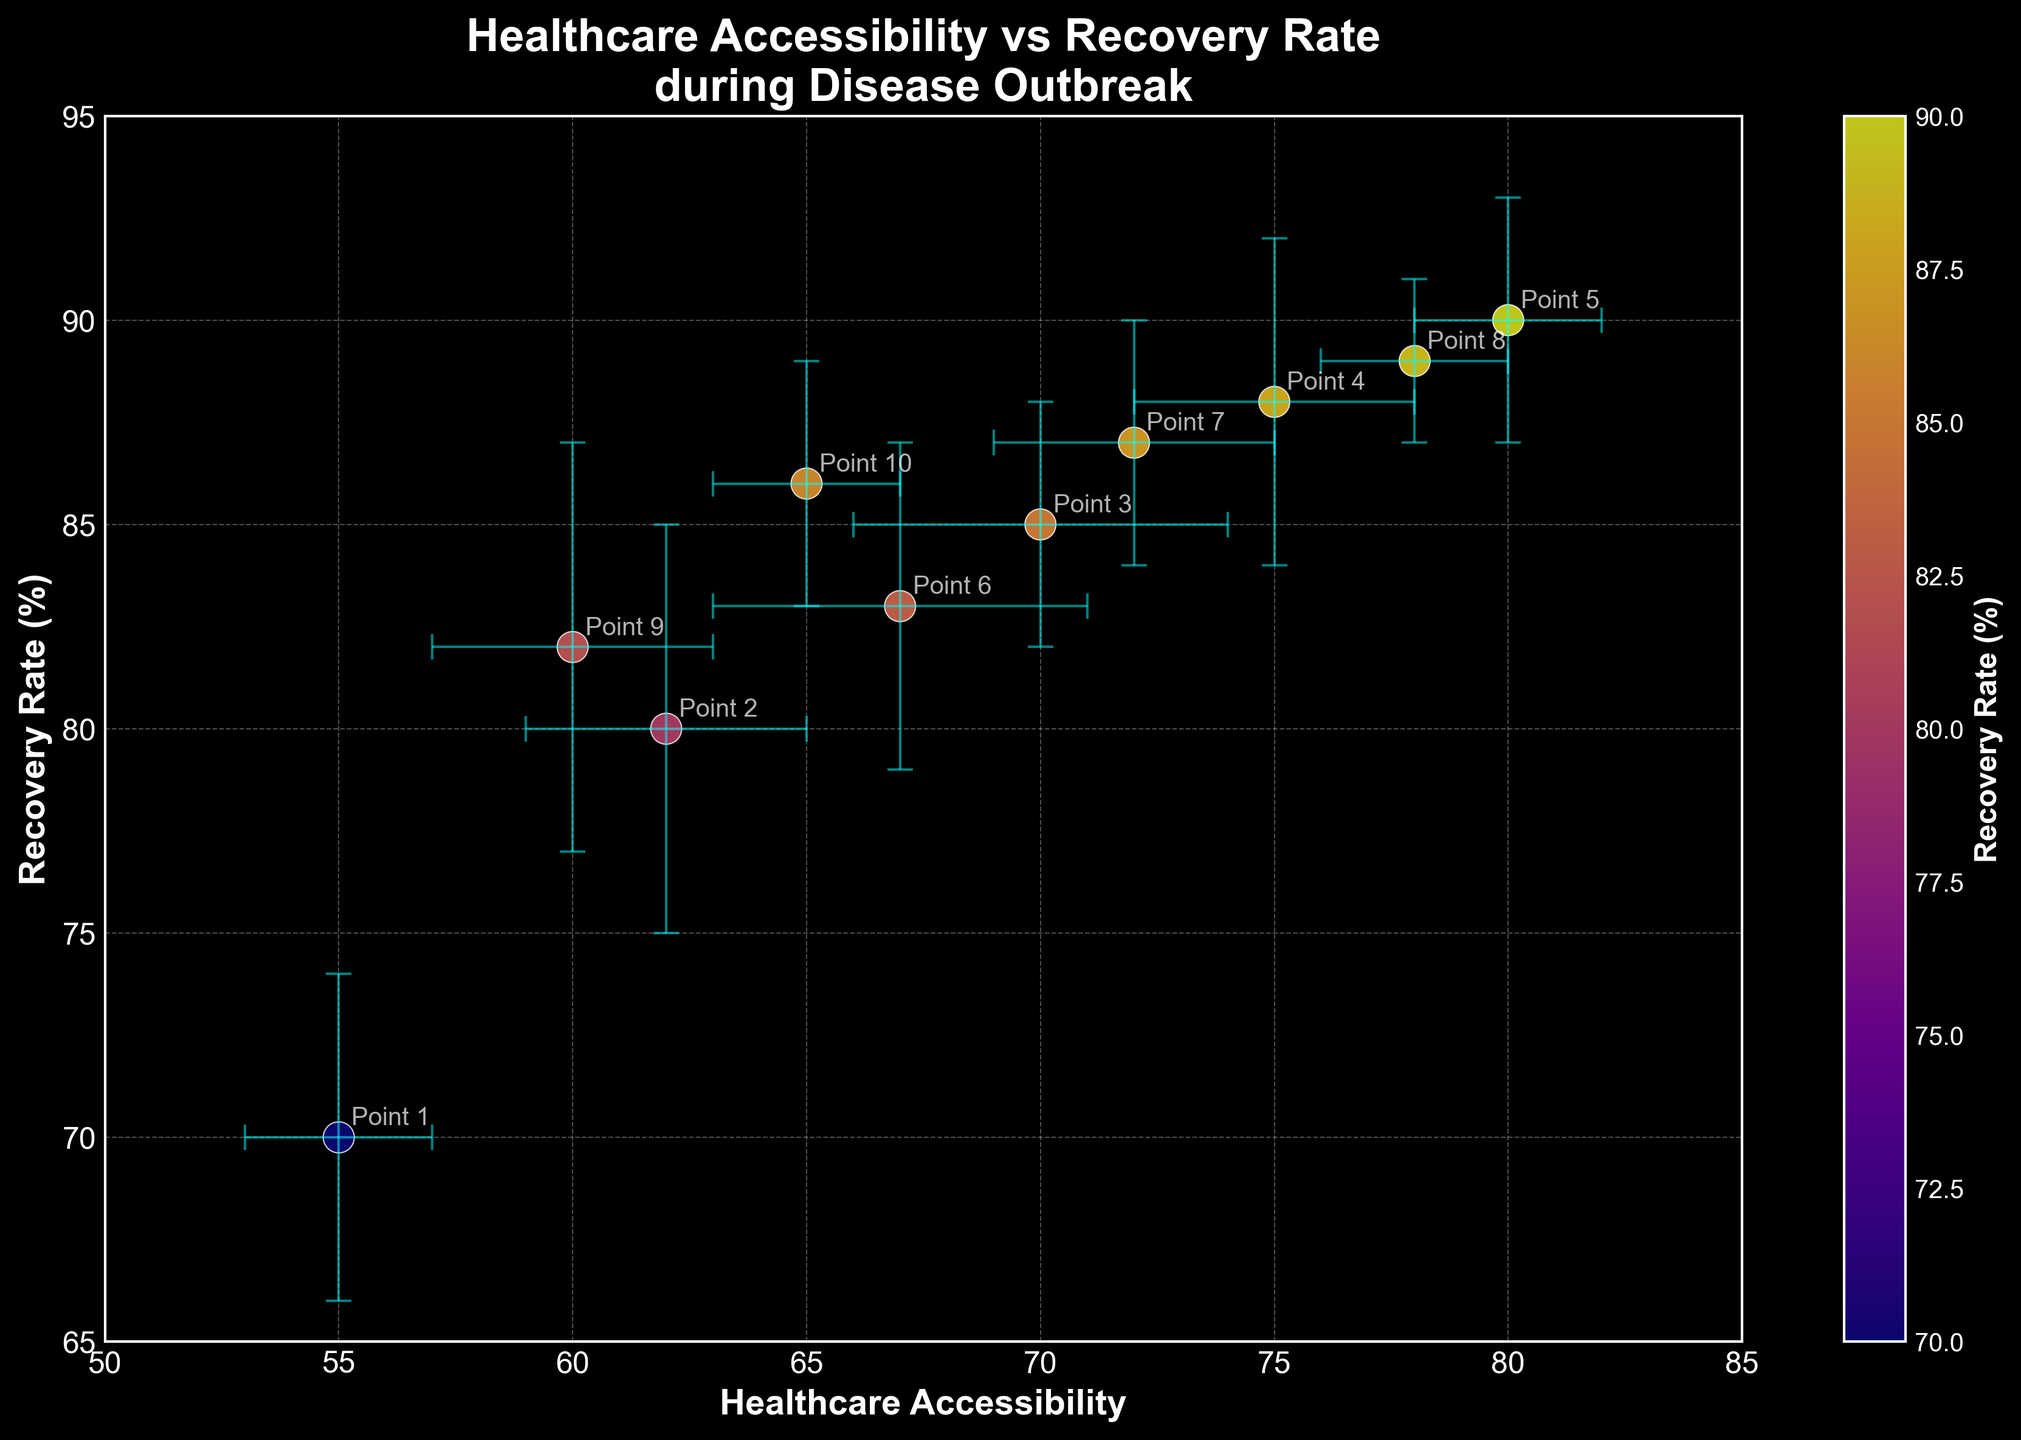What's the title of the figure? The title is displayed prominently at the top of the figure.
Answer: Healthcare Accessibility vs Recovery Rate during Disease Outbreak What variables are plotted on the x and y axes? The labels describe the variables: the x-axis represents Healthcare Accessibility, and the y-axis represents Recovery Rate (%).
Answer: Healthcare Accessibility and Recovery Rate (%) What color indicates the highest recovery rate in the figure? By observing the color gradient in the scatter plot, the brightest or most intense color in the color bar represents the highest recovery rate.
Answer: The most intense color on the colorbar, likely deep purple or neon yellow How many data points are represented in the scatter plot? We can count the number of individual points shown in the scatter plot.
Answer: 10 Which data point has the highest recovery rate? We compare the y-values (Recovery Rate) and identify the point with the highest value.
Answer: Point 5 (90%) What is the range of healthcare accessibility values shown on the x-axis? We can determine the minimum and maximum values indicated on the x-axis to find the range.
Answer: 50 to 85 Which points have error bars that overlap for both healthcare accessibility and recovery rates? By inspecting the figure, we determine which error bars overlap in both axes.
Answer: Point 4 (75, 88) and Point 9 (60, 82) What is the average recovery rate of all data points? Add all recovery rates and divide by the number of data points: (70 + 80 + 85 + 88 + 90 + 83 + 87 + 89 + 82 + 86) / 10.
Answer: 84 Does higher healthcare accessibility result in higher recovery rates based on the graph? We observe the trend in the scatter plot; generally, as healthcare accessibility increases, recovery rates seem to increase too.
Answer: Yes, higher healthcare accessibility generally results in higher recovery rates What can you say about the relationship between Healthcare Accessibility and Recovery Rate based on the scatter plot? By observing the scatter plot, a trend can be noticed where an increase in healthcare accessibility correlates with an increase in recovery rates. This suggests a positive correlation. Error bars provide a range within which true values may lie, indicating some degree of variability around each data point.
Answer: There is a positive correlation between Healthcare Accessibility and Recovery Rate, with some variability indicated by error bars 